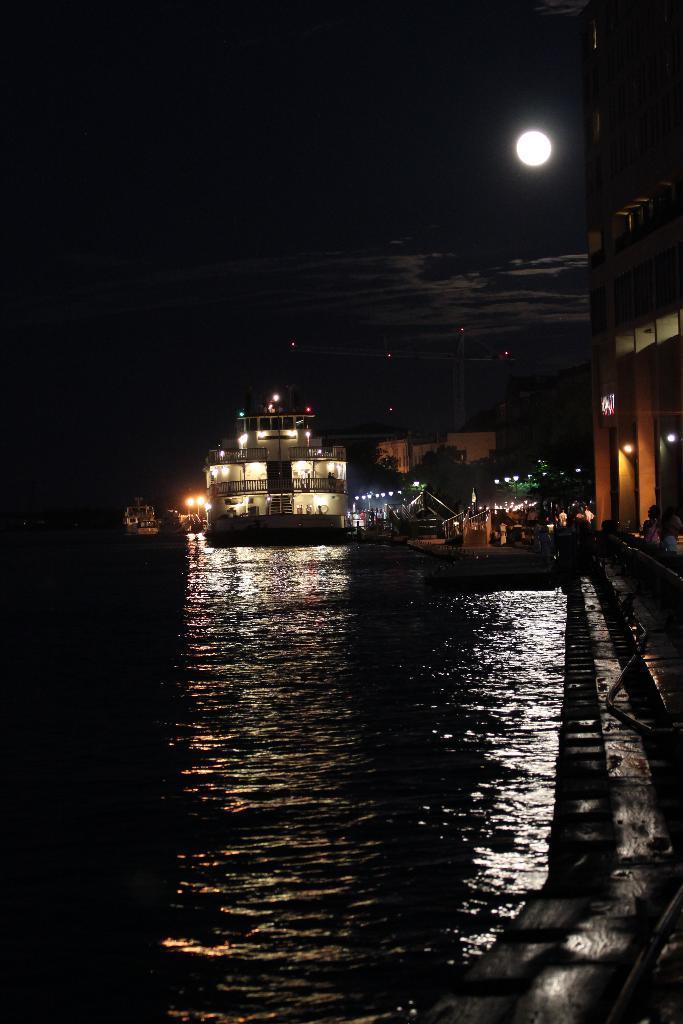How would you summarize this image in a sentence or two? In the foreground I can see water, fence, crowd, buildings, lights, trees and so on. In the background I can see boats in the water, moon and the sky. This image is taken may be during night. 